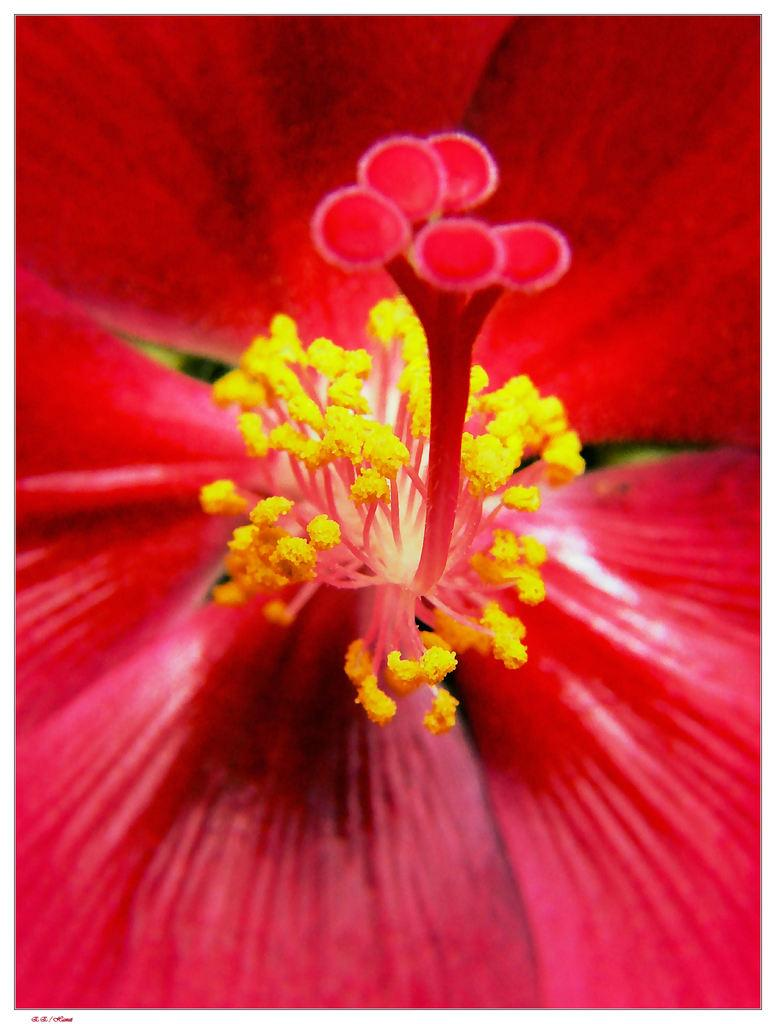What is the main subject of the image? The main subject of the image is a flower. Can you describe the colors of the flower? The flower has red and yellow colors. What type of advertisement is being displayed on the flower in the image? There is no advertisement present in the image; it features a flower with red and yellow colors. How many cows are visible in the image? There are no cows present in the image. 